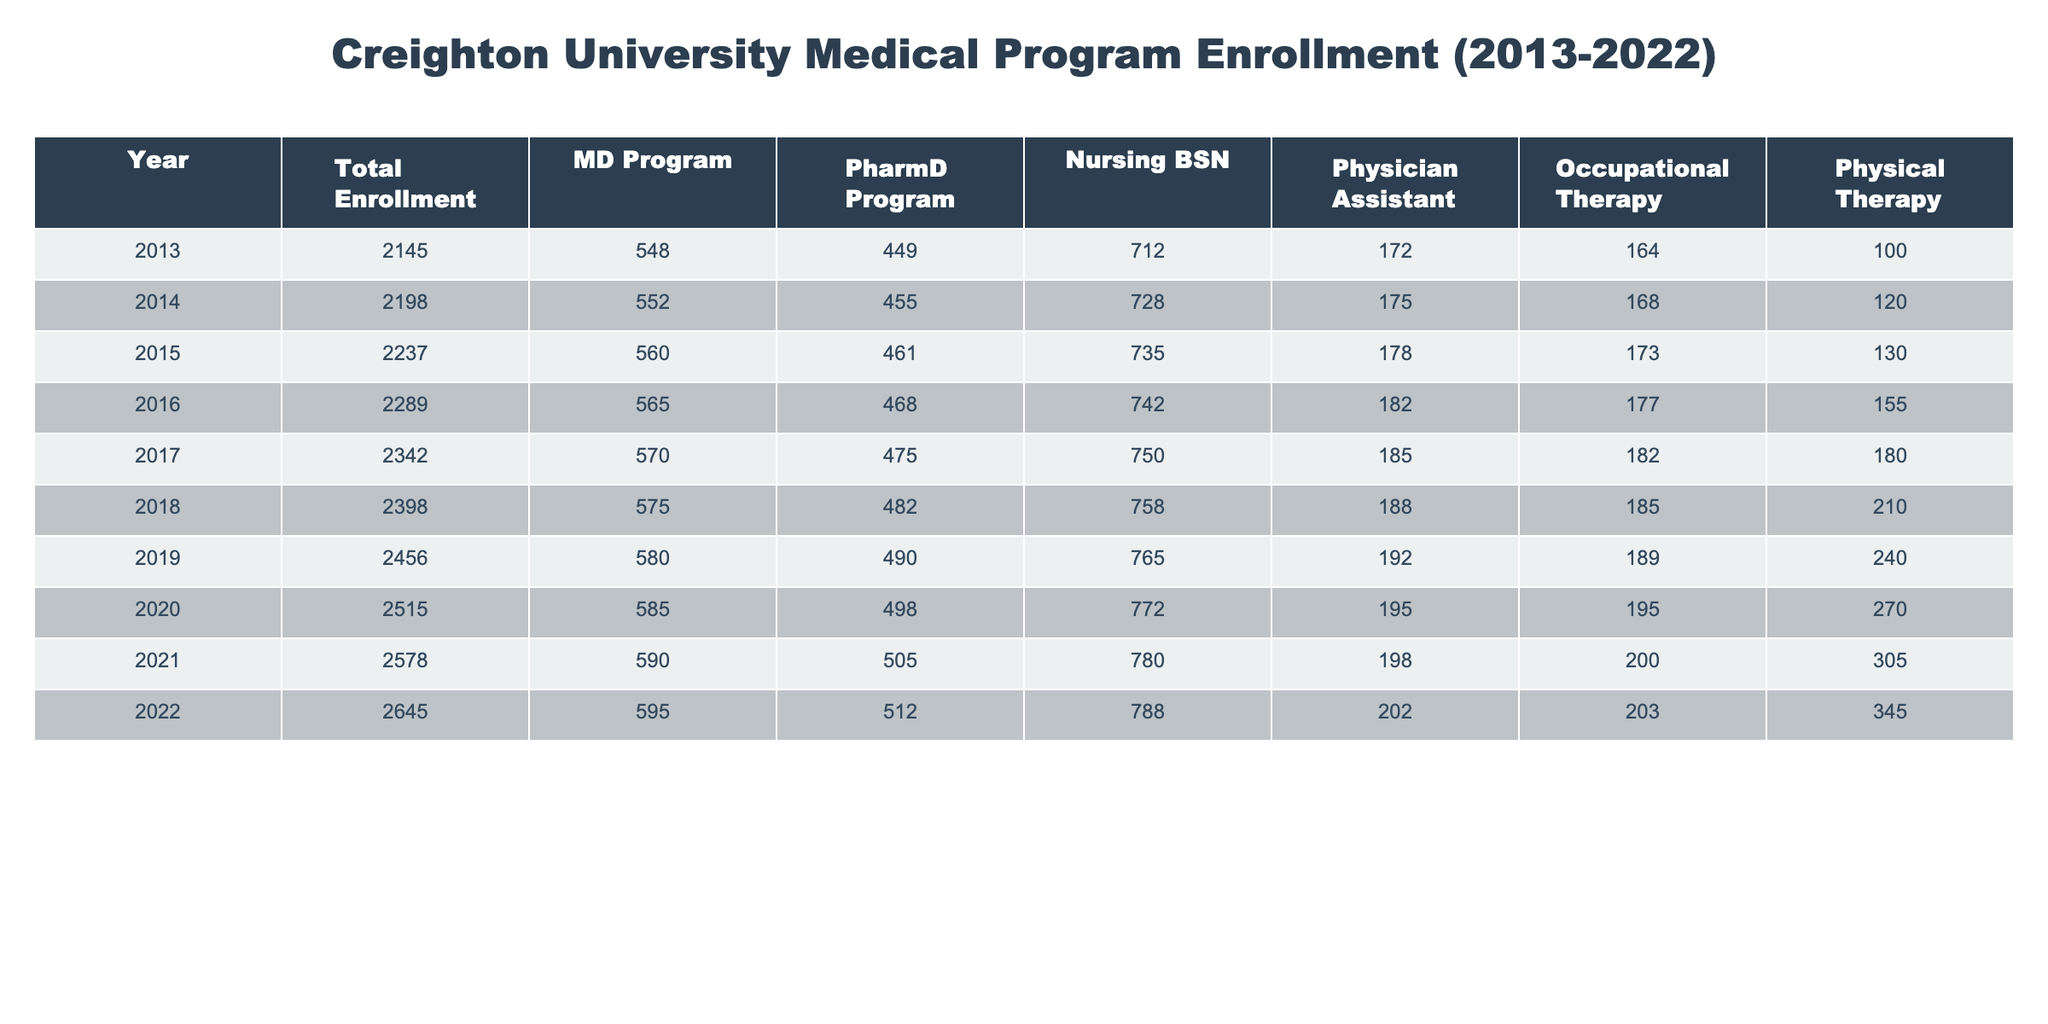What was the total enrollment in 2018? Looking at the table, the total enrollment for the year 2018 is directly listed under the Total Enrollment column, which shows 2398.
Answer: 2398 Which program had the highest enrollment in 2021? The table shows that, in 2021, the MD Program had the highest enrollment with 590 students, compared to the other programs' enrollments listed in the same row.
Answer: MD Program What is the rise in enrollment from 2013 to 2022? The Total Enrollment for 2013 was 2145, and for 2022 it is 2645. The difference is calculated as 2645 - 2145 = 500.
Answer: 500 What was the average enrollment for the Nursing BSN program over the decade? To find the average for the Nursing BSN program, we sum the enrollments from 2013 to 2022: 712 + 728 + 735 + 742 + 750 + 758 + 765 + 772 + 780 + 788 = 7580. Then we divide by the number of years, which is 10: 7580/10 = 758.
Answer: 758 Was there an increase in enrollment for the PharmD program from 2013 to 2022? In 2013, the PharmD program had an enrollment of 449, and in 2022, it had 512. Since 512 is greater than 449, there was indeed an increase in enrollment.
Answer: Yes Which program shows the greatest increase in enrollment from 2013 to 2022? To determine which program had the greatest increase, we look at the enrollment numbers from 2013 to 2022 for each program. The increases are: MD: 590 - 548 = 42, PharmD: 512 - 449 = 63, Nursing: 788 - 712 = 76, PA: 202 - 172 = 30, OT: 203 - 164 = 39, PT: 345 - 100 = 245. The Physical Therapy program had the greatest increase of 245.
Answer: Physical Therapy What percentage of the total enrollment in 2020 was from the MD program? In 2020, the total enrollment was 2515 and the MD program had 585 students. To find the percentage, we calculate (585 / 2515) * 100, which equals approximately 23.2%.
Answer: 23.2% How many more students were enrolled in the Physical Therapy program in 2022 compared to 2017? The enrollment in the Physical Therapy program in 2022 was 345, and in 2017 it was 180. The difference is calculated as 345 - 180 = 165 more students in 2022.
Answer: 165 